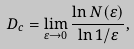<formula> <loc_0><loc_0><loc_500><loc_500>D _ { c } = \lim _ { \varepsilon \rightarrow 0 } \frac { \ln N ( \varepsilon ) } { \ln 1 / \varepsilon } ,</formula> 